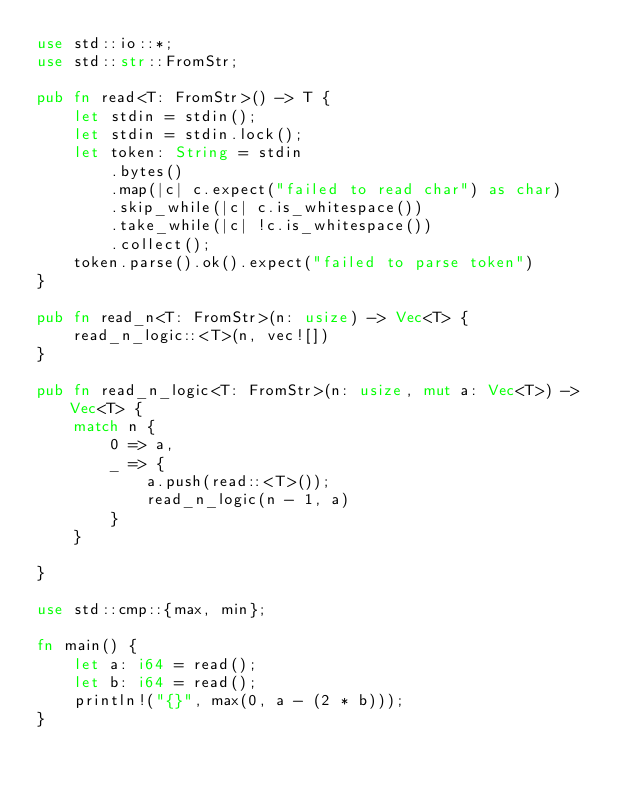Convert code to text. <code><loc_0><loc_0><loc_500><loc_500><_Rust_>use std::io::*;
use std::str::FromStr;

pub fn read<T: FromStr>() -> T {
    let stdin = stdin();
    let stdin = stdin.lock();
    let token: String = stdin
        .bytes()
        .map(|c| c.expect("failed to read char") as char)
        .skip_while(|c| c.is_whitespace())
        .take_while(|c| !c.is_whitespace())
        .collect();
    token.parse().ok().expect("failed to parse token")
}

pub fn read_n<T: FromStr>(n: usize) -> Vec<T> {
    read_n_logic::<T>(n, vec![])
}

pub fn read_n_logic<T: FromStr>(n: usize, mut a: Vec<T>) -> Vec<T> {
    match n {
        0 => a,
        _ => {
            a.push(read::<T>());
            read_n_logic(n - 1, a)
        }
    }

}

use std::cmp::{max, min};

fn main() {
    let a: i64 = read();
    let b: i64 = read();
    println!("{}", max(0, a - (2 * b)));
}
</code> 